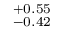Convert formula to latex. <formula><loc_0><loc_0><loc_500><loc_500>^ { + 0 . 5 5 } _ { - 0 . 4 2 }</formula> 